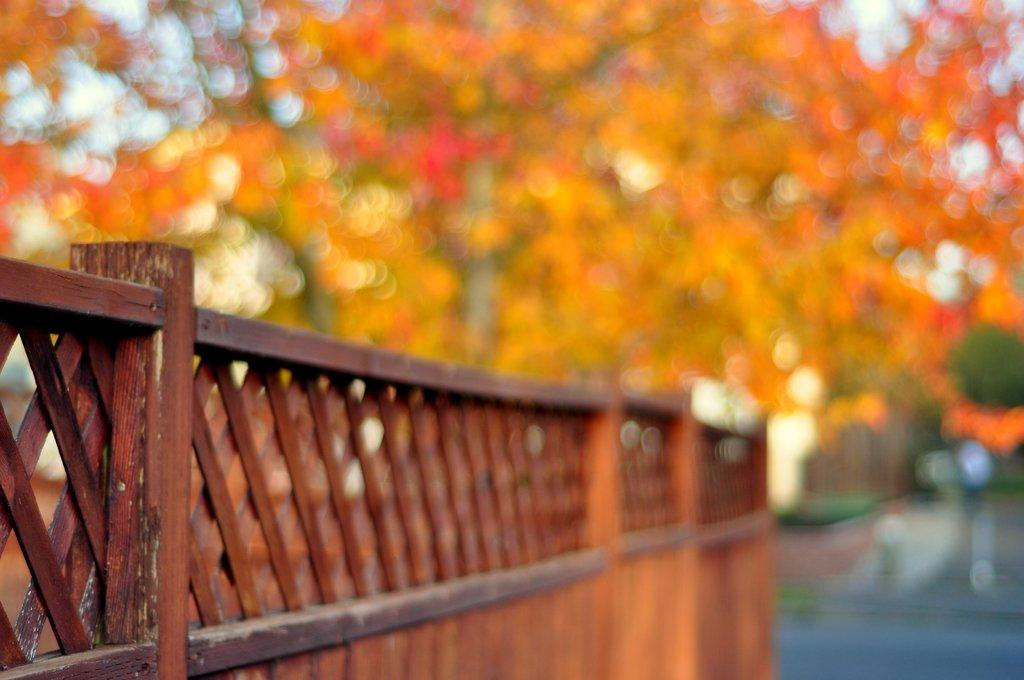What type of fence is visible in the image? There is a wooden fence in the image. Can you describe the background of the image? The background of the image is blurred. What type of floor can be seen in the image? There is no floor visible in the image; it only features a wooden fence and a blurred background. What type of can is present in the image? There is no can present in the image. 